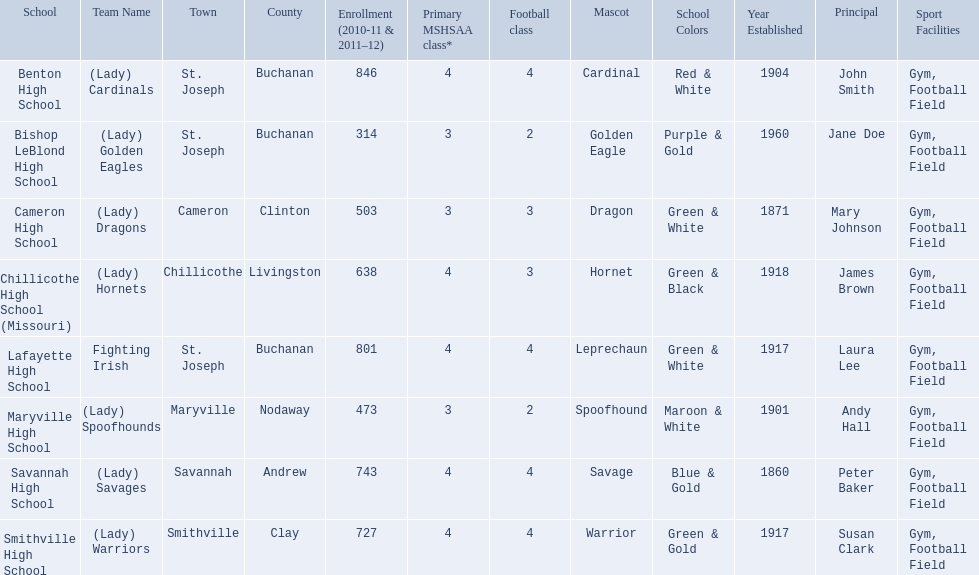What are all of the schools? Benton High School, Bishop LeBlond High School, Cameron High School, Chillicothe High School (Missouri), Lafayette High School, Maryville High School, Savannah High School, Smithville High School. How many football classes do they have? 4, 2, 3, 3, 4, 2, 4, 4. What about their enrollment? 846, 314, 503, 638, 801, 473, 743, 727. Which schools have 3 football classes? Cameron High School, Chillicothe High School (Missouri). And of those schools, which has 638 students? Chillicothe High School (Missouri). 